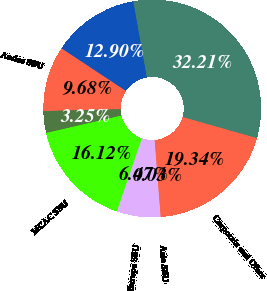Convert chart. <chart><loc_0><loc_0><loc_500><loc_500><pie_chart><fcel>Year Ended December 31<fcel>US SBU<fcel>Andes SBU<fcel>Brazil SBU<fcel>MCAC SBU<fcel>Europe SBU<fcel>Asia SBU<fcel>Corporate and Other<nl><fcel>32.21%<fcel>12.9%<fcel>9.68%<fcel>3.25%<fcel>16.12%<fcel>6.47%<fcel>0.03%<fcel>19.34%<nl></chart> 